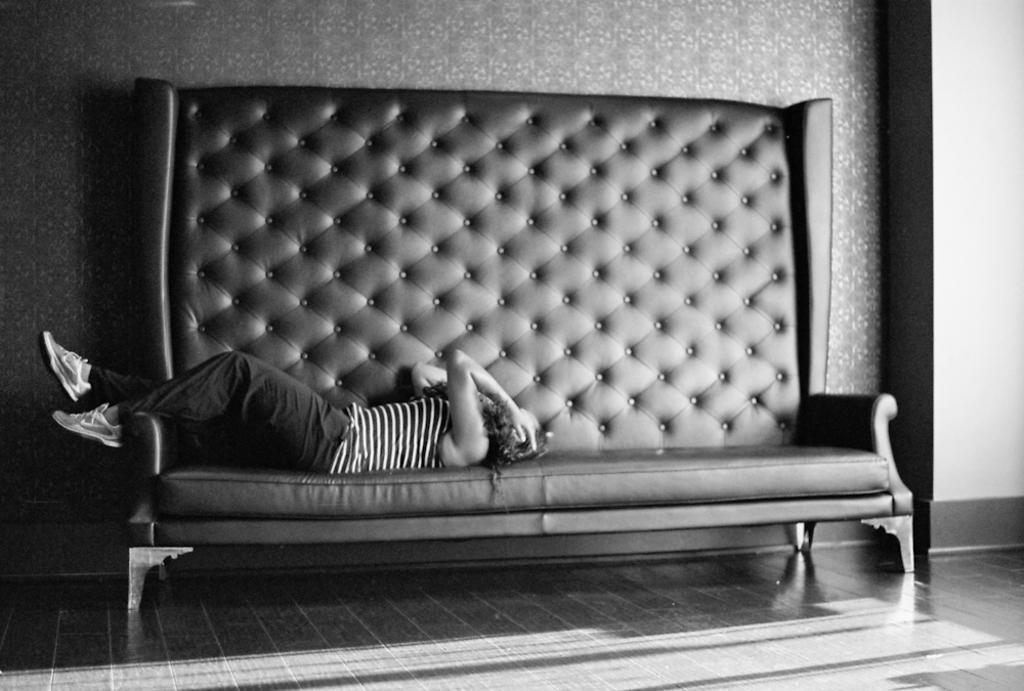Can you describe this image briefly? This person laying on sofa. On the background we can see wall. This is floor. 